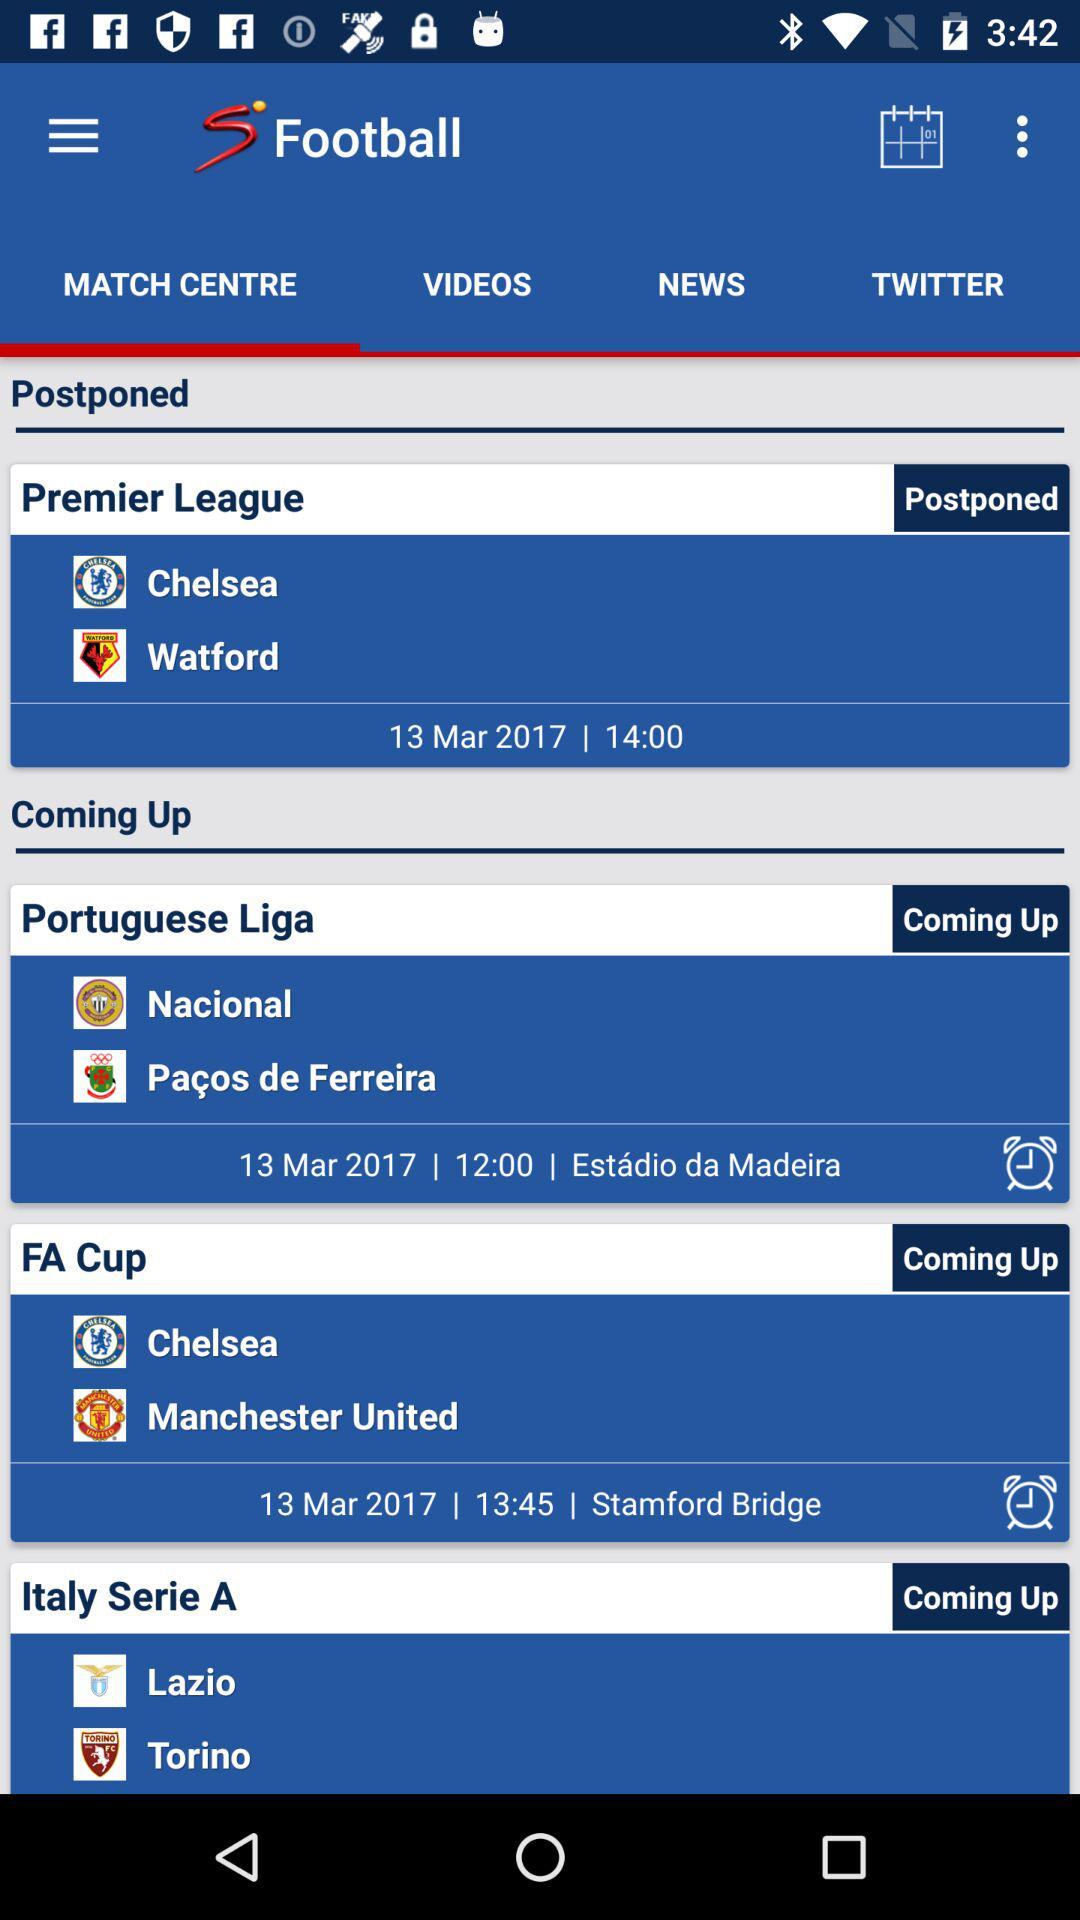How many postponed matches are there?
Answer the question using a single word or phrase. 1 